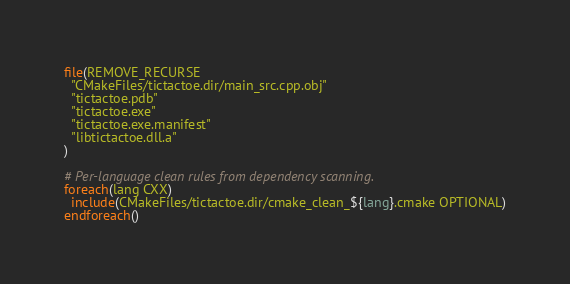Convert code to text. <code><loc_0><loc_0><loc_500><loc_500><_CMake_>file(REMOVE_RECURSE
  "CMakeFiles/tictactoe.dir/main_src.cpp.obj"
  "tictactoe.pdb"
  "tictactoe.exe"
  "tictactoe.exe.manifest"
  "libtictactoe.dll.a"
)

# Per-language clean rules from dependency scanning.
foreach(lang CXX)
  include(CMakeFiles/tictactoe.dir/cmake_clean_${lang}.cmake OPTIONAL)
endforeach()
</code> 